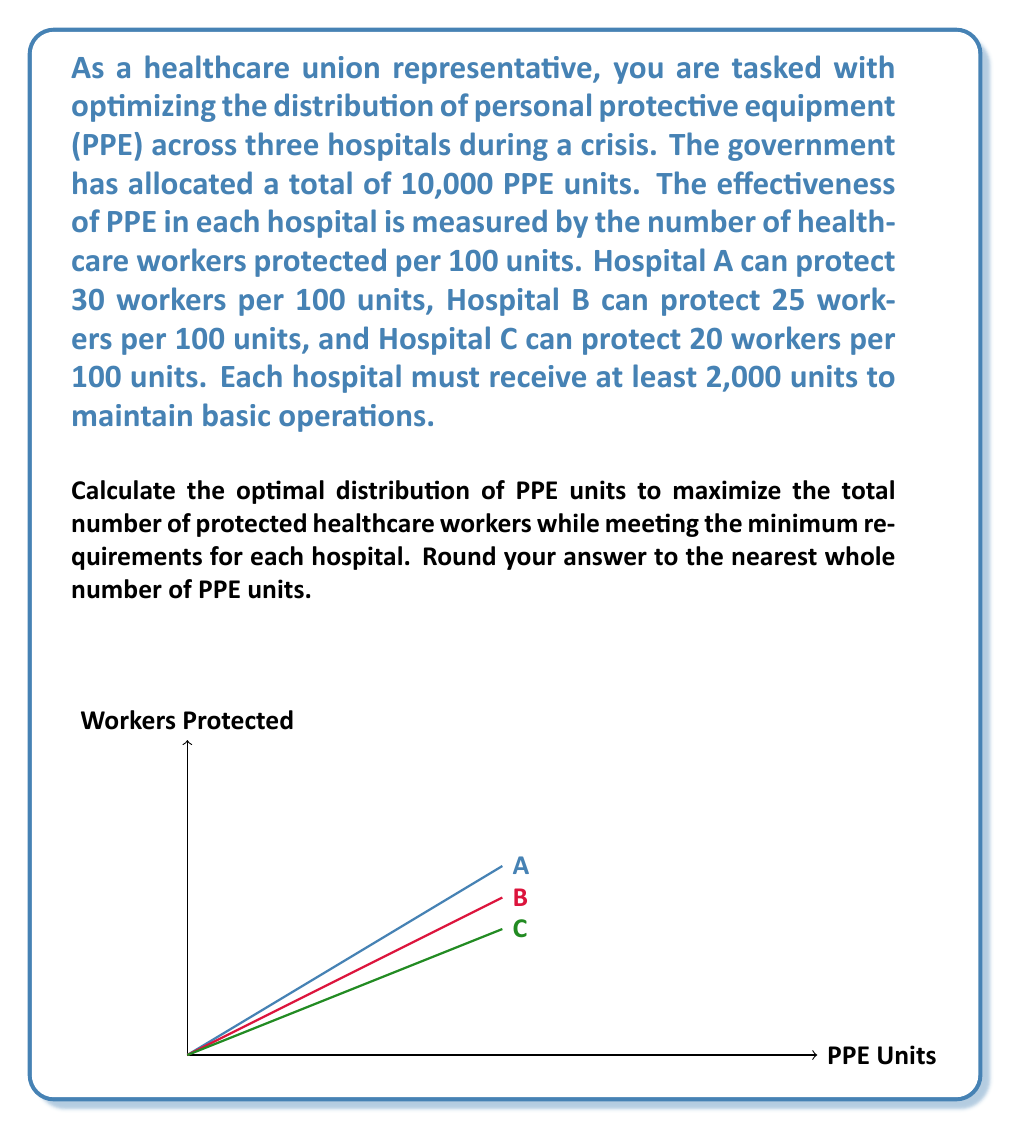Show me your answer to this math problem. Let's approach this step-by-step using the principle of marginal utility:

1) First, we need to distribute the minimum required units:
   Hospital A: 2,000 units
   Hospital B: 2,000 units
   Hospital C: 2,000 units
   Total: 6,000 units

2) We have 4,000 units left to distribute optimally.

3) Let's calculate the effectiveness of each hospital per unit:
   Hospital A: 30/100 = 0.3 workers/unit
   Hospital B: 25/100 = 0.25 workers/unit
   Hospital C: 20/100 = 0.2 workers/unit

4) We should allocate the remaining units to the hospital with the highest effectiveness first. In this case, it's Hospital A.

5) The optimal distribution would be:
   Hospital A: 2,000 + 4,000 = 6,000 units
   Hospital B: 2,000 units
   Hospital C: 2,000 units

6) Let's calculate the total number of protected workers:
   Hospital A: 6,000 * 0.3 = 1,800 workers
   Hospital B: 2,000 * 0.25 = 500 workers
   Hospital C: 2,000 * 0.2 = 400 workers

7) Total protected workers: 1,800 + 500 + 400 = 2,700 workers

Therefore, the optimal distribution is 6,000 units to Hospital A, 2,000 units to Hospital B, and 2,000 units to Hospital C.
Answer: (6000, 2000, 2000) 